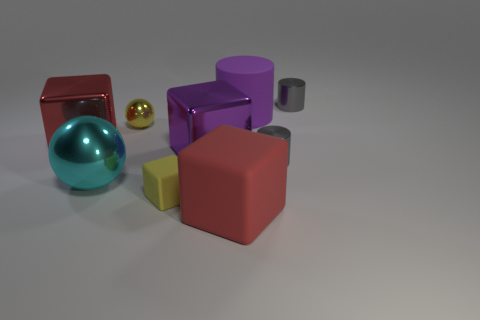Subtract all purple metal blocks. How many blocks are left? 3 Subtract all brown spheres. How many red cubes are left? 2 Subtract all purple cylinders. How many cylinders are left? 2 Subtract all balls. How many objects are left? 7 Add 7 big shiny spheres. How many big shiny spheres exist? 8 Subtract 1 purple cylinders. How many objects are left? 8 Subtract all green cylinders. Subtract all yellow blocks. How many cylinders are left? 3 Subtract all purple blocks. Subtract all cubes. How many objects are left? 4 Add 8 tiny metallic balls. How many tiny metallic balls are left? 9 